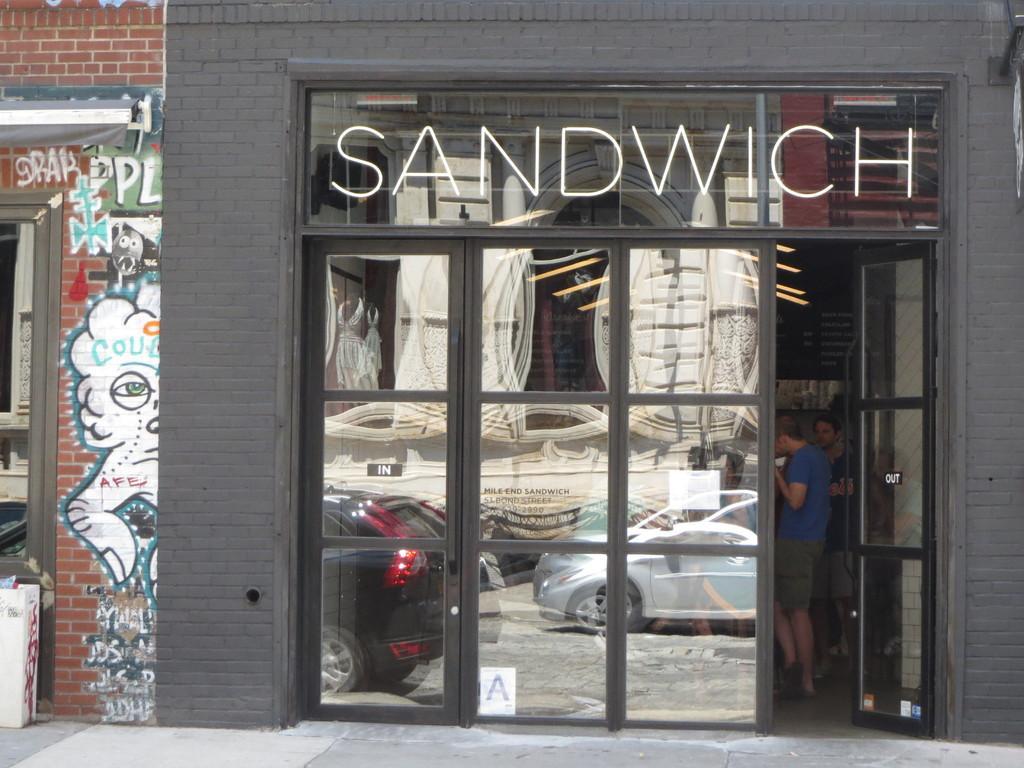How would you summarize this image in a sentence or two? In this image in the center there is one store, in that store there are two persons who are standing. On the left side there is a wall, on the wall there is some art and a window and in the center there is one glass door. At the bottom there is a walkway. 